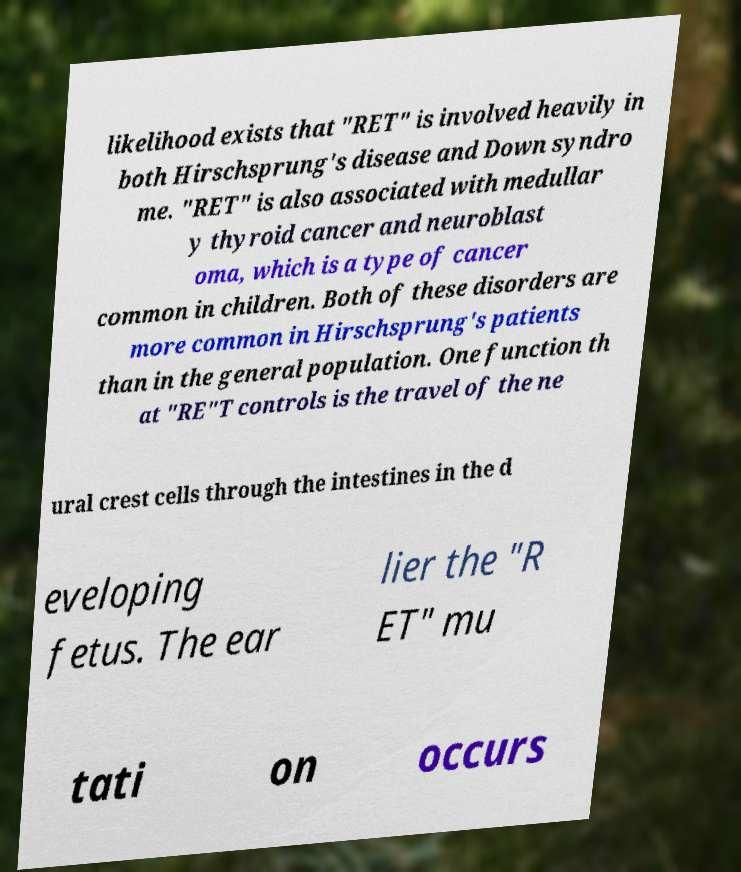There's text embedded in this image that I need extracted. Can you transcribe it verbatim? likelihood exists that "RET" is involved heavily in both Hirschsprung's disease and Down syndro me. "RET" is also associated with medullar y thyroid cancer and neuroblast oma, which is a type of cancer common in children. Both of these disorders are more common in Hirschsprung's patients than in the general population. One function th at "RE"T controls is the travel of the ne ural crest cells through the intestines in the d eveloping fetus. The ear lier the "R ET" mu tati on occurs 